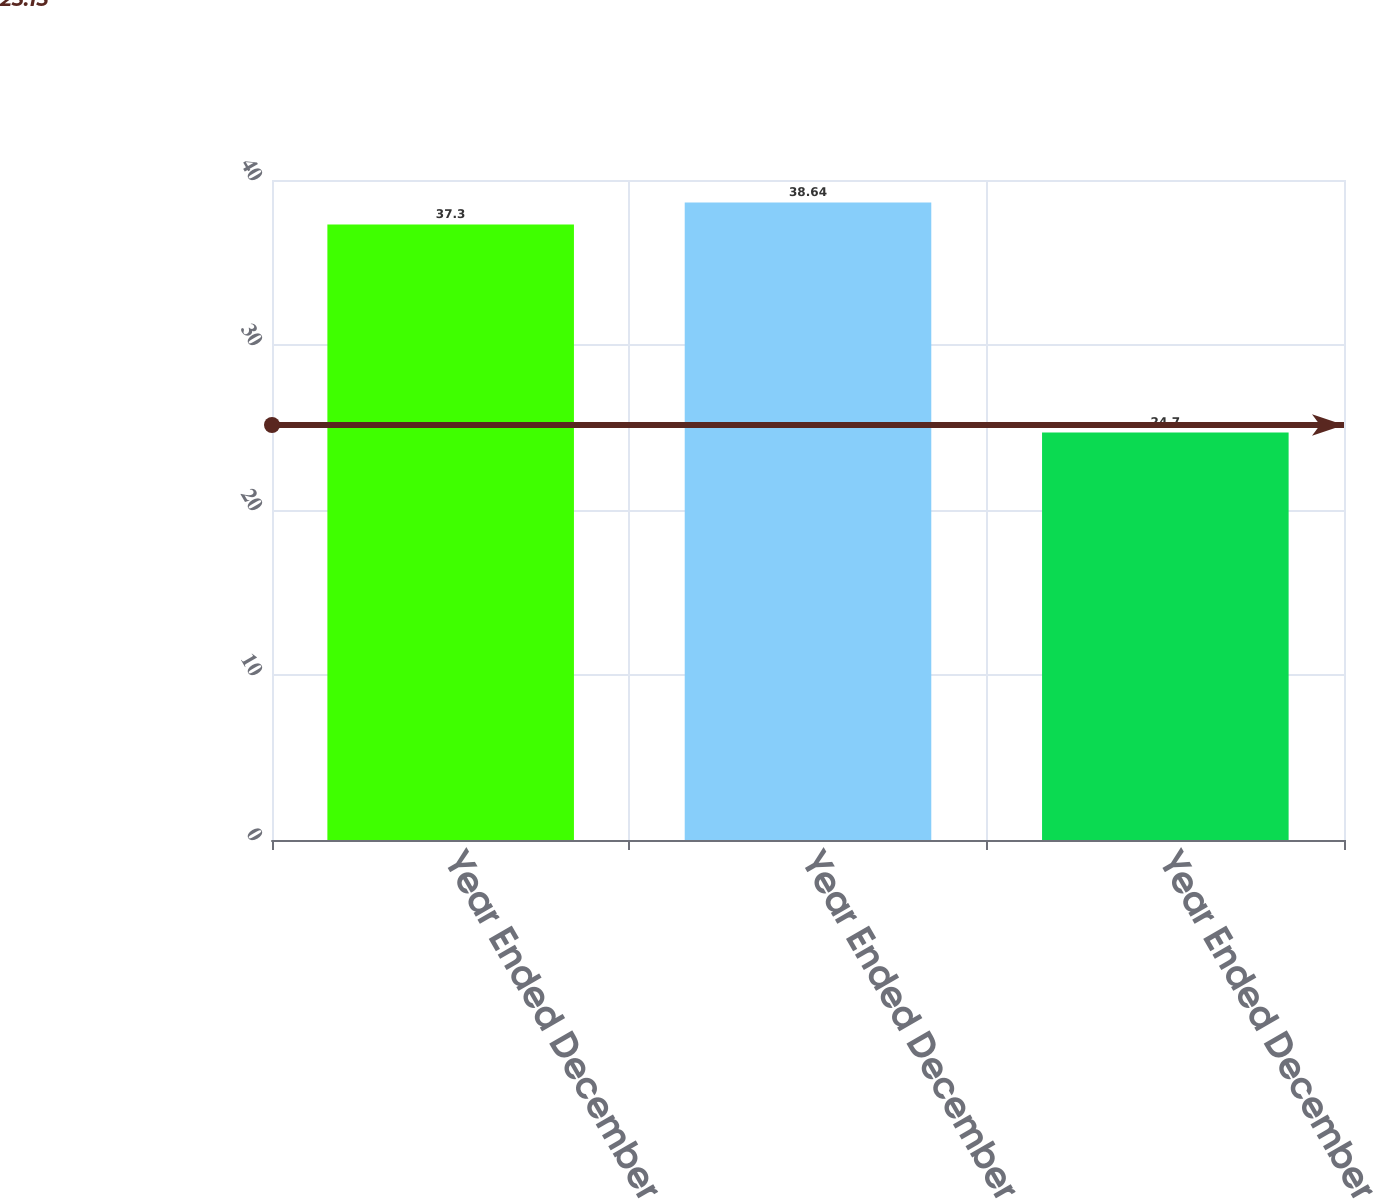<chart> <loc_0><loc_0><loc_500><loc_500><bar_chart><fcel>Year Ended December 31 2018<fcel>Year Ended December 31 2017<fcel>Year Ended December 31 2016<nl><fcel>37.3<fcel>38.64<fcel>24.7<nl></chart> 